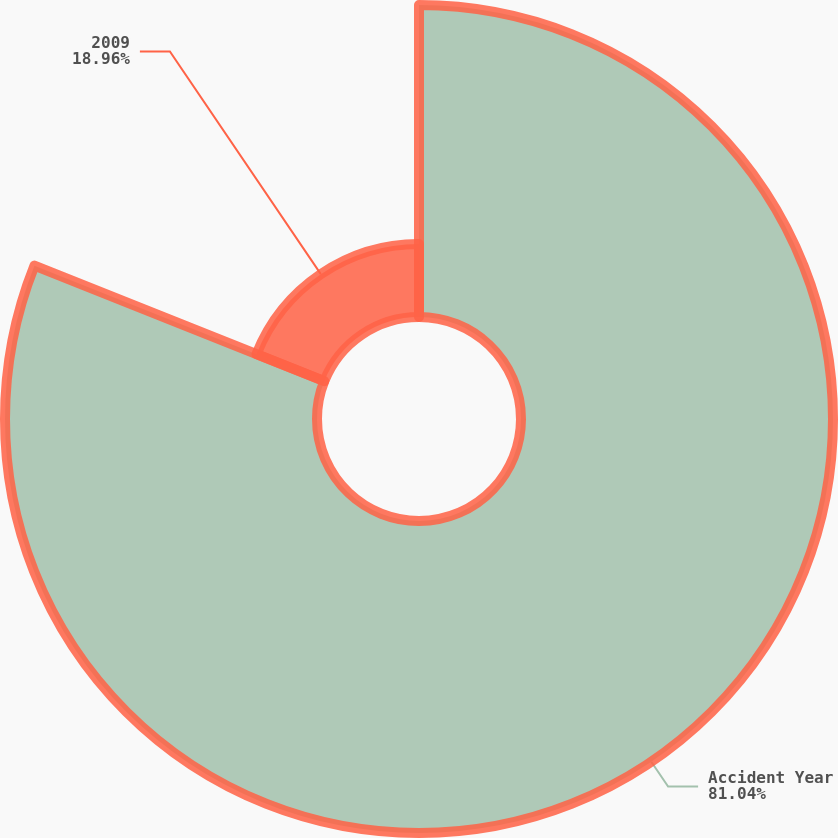Convert chart. <chart><loc_0><loc_0><loc_500><loc_500><pie_chart><fcel>Accident Year<fcel>2009<nl><fcel>81.04%<fcel>18.96%<nl></chart> 